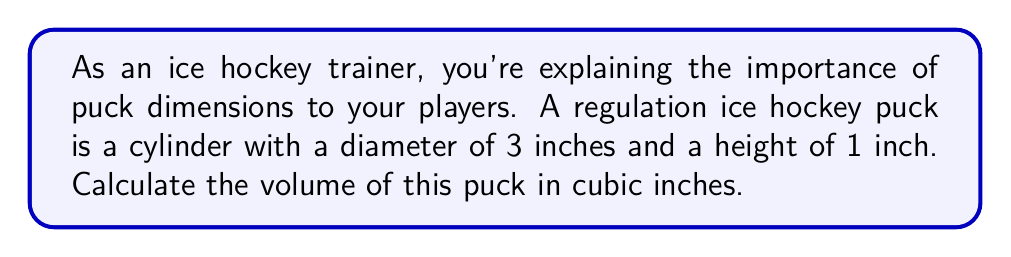What is the answer to this math problem? To calculate the volume of a cylinder (in this case, the hockey puck), we use the formula:

$$V = \pi r^2 h$$

Where:
$V$ = volume
$r$ = radius of the base
$h$ = height of the cylinder

Step 1: Determine the radius
The diameter is 3 inches, so the radius is half of that:
$r = 3 \div 2 = 1.5$ inches

Step 2: Use the given height
$h = 1$ inch

Step 3: Substitute the values into the formula
$$V = \pi (1.5)^2 (1)$$

Step 4: Calculate
$$V = \pi (2.25) (1)$$
$$V = 2.25\pi$$

Step 5: Use 3.14159 as an approximation for $\pi$
$$V \approx 2.25 * 3.14159$$
$$V \approx 7.06858$$

Step 6: Round to two decimal places
$$V \approx 7.07 \text{ cubic inches}$$
Answer: $7.07 \text{ in}^3$ 